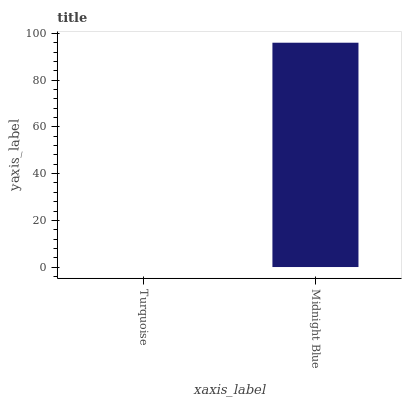Is Turquoise the minimum?
Answer yes or no. Yes. Is Midnight Blue the maximum?
Answer yes or no. Yes. Is Midnight Blue the minimum?
Answer yes or no. No. Is Midnight Blue greater than Turquoise?
Answer yes or no. Yes. Is Turquoise less than Midnight Blue?
Answer yes or no. Yes. Is Turquoise greater than Midnight Blue?
Answer yes or no. No. Is Midnight Blue less than Turquoise?
Answer yes or no. No. Is Midnight Blue the high median?
Answer yes or no. Yes. Is Turquoise the low median?
Answer yes or no. Yes. Is Turquoise the high median?
Answer yes or no. No. Is Midnight Blue the low median?
Answer yes or no. No. 